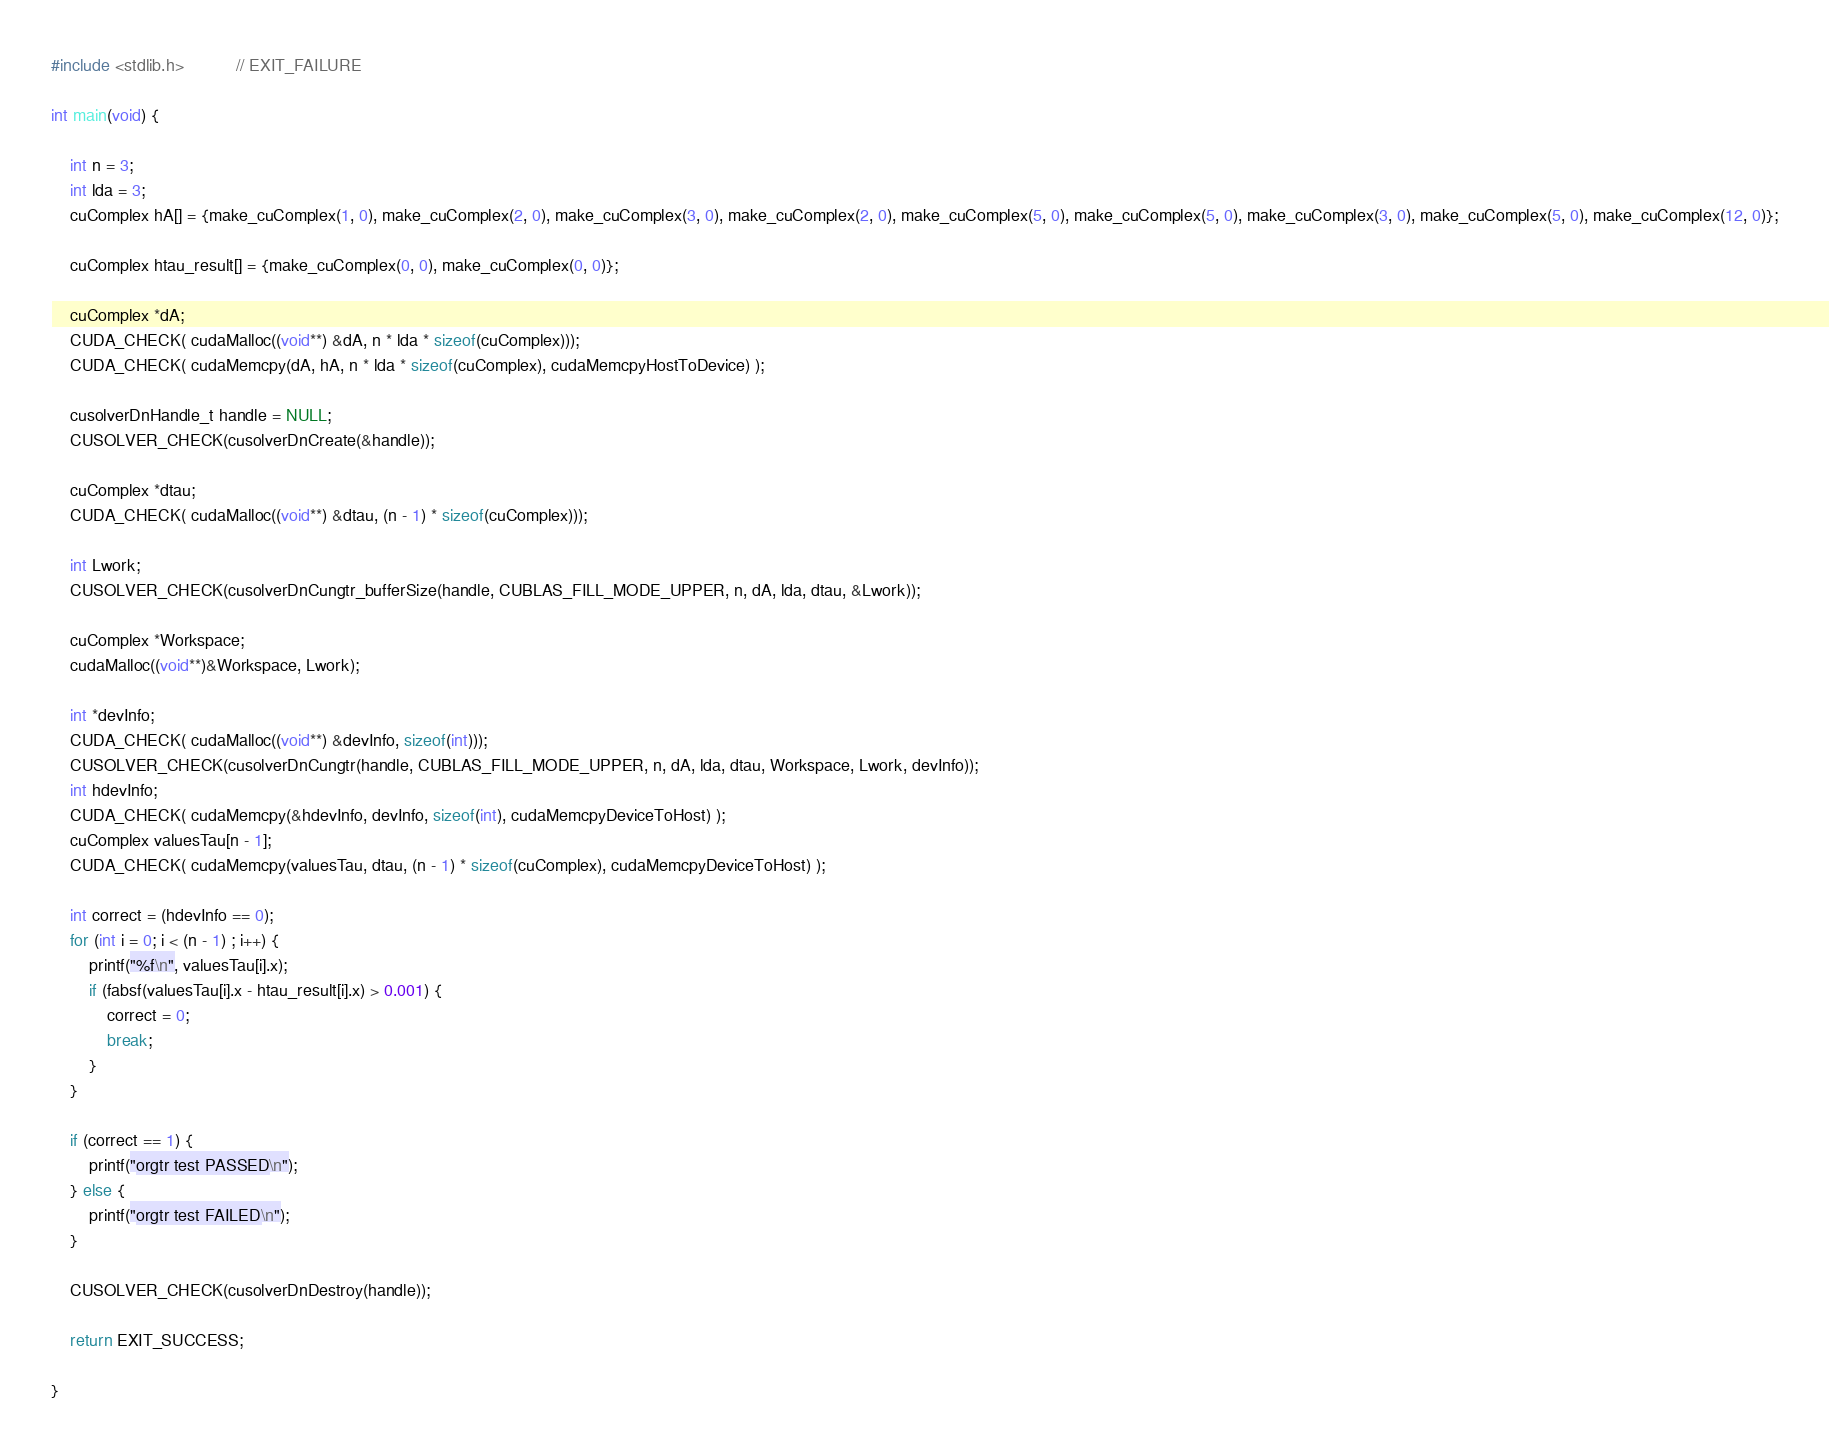Convert code to text. <code><loc_0><loc_0><loc_500><loc_500><_Cuda_>#include <stdlib.h>           // EXIT_FAILURE

int main(void) {

    int n = 3;
    int lda = 3;
    cuComplex hA[] = {make_cuComplex(1, 0), make_cuComplex(2, 0), make_cuComplex(3, 0), make_cuComplex(2, 0), make_cuComplex(5, 0), make_cuComplex(5, 0), make_cuComplex(3, 0), make_cuComplex(5, 0), make_cuComplex(12, 0)};

    cuComplex htau_result[] = {make_cuComplex(0, 0), make_cuComplex(0, 0)};

    cuComplex *dA;
    CUDA_CHECK( cudaMalloc((void**) &dA, n * lda * sizeof(cuComplex)));
    CUDA_CHECK( cudaMemcpy(dA, hA, n * lda * sizeof(cuComplex), cudaMemcpyHostToDevice) );

    cusolverDnHandle_t handle = NULL;
    CUSOLVER_CHECK(cusolverDnCreate(&handle));

    cuComplex *dtau;
    CUDA_CHECK( cudaMalloc((void**) &dtau, (n - 1) * sizeof(cuComplex)));

    int Lwork;
    CUSOLVER_CHECK(cusolverDnCungtr_bufferSize(handle, CUBLAS_FILL_MODE_UPPER, n, dA, lda, dtau, &Lwork));

    cuComplex *Workspace;
    cudaMalloc((void**)&Workspace, Lwork);

    int *devInfo;
    CUDA_CHECK( cudaMalloc((void**) &devInfo, sizeof(int)));
    CUSOLVER_CHECK(cusolverDnCungtr(handle, CUBLAS_FILL_MODE_UPPER, n, dA, lda, dtau, Workspace, Lwork, devInfo));
    int hdevInfo;
    CUDA_CHECK( cudaMemcpy(&hdevInfo, devInfo, sizeof(int), cudaMemcpyDeviceToHost) );
    cuComplex valuesTau[n - 1];
    CUDA_CHECK( cudaMemcpy(valuesTau, dtau, (n - 1) * sizeof(cuComplex), cudaMemcpyDeviceToHost) );

    int correct = (hdevInfo == 0);
    for (int i = 0; i < (n - 1) ; i++) {
        printf("%f\n", valuesTau[i].x);
        if (fabsf(valuesTau[i].x - htau_result[i].x) > 0.001) {
            correct = 0;
            break;
        }
    }

    if (correct == 1) {
        printf("orgtr test PASSED\n");
    } else {
        printf("orgtr test FAILED\n");
    }

    CUSOLVER_CHECK(cusolverDnDestroy(handle));

    return EXIT_SUCCESS;

}</code> 